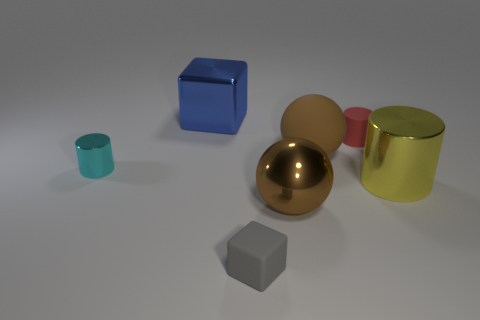Add 1 tiny red metallic balls. How many objects exist? 8 Subtract all cylinders. How many objects are left? 4 Add 7 tiny blue matte things. How many tiny blue matte things exist? 7 Subtract 0 purple cylinders. How many objects are left? 7 Subtract all small matte cylinders. Subtract all matte balls. How many objects are left? 5 Add 6 tiny cylinders. How many tiny cylinders are left? 8 